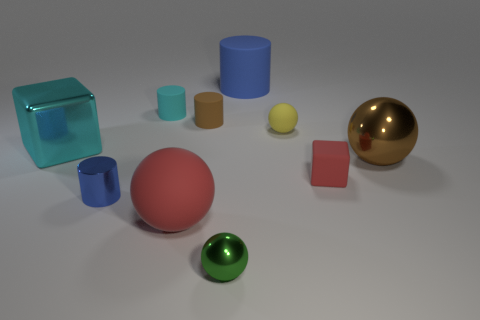Subtract all cylinders. How many objects are left? 6 Subtract all blue matte spheres. Subtract all small shiny cylinders. How many objects are left? 9 Add 7 small red things. How many small red things are left? 8 Add 9 large cyan shiny spheres. How many large cyan shiny spheres exist? 9 Subtract 0 yellow cylinders. How many objects are left? 10 